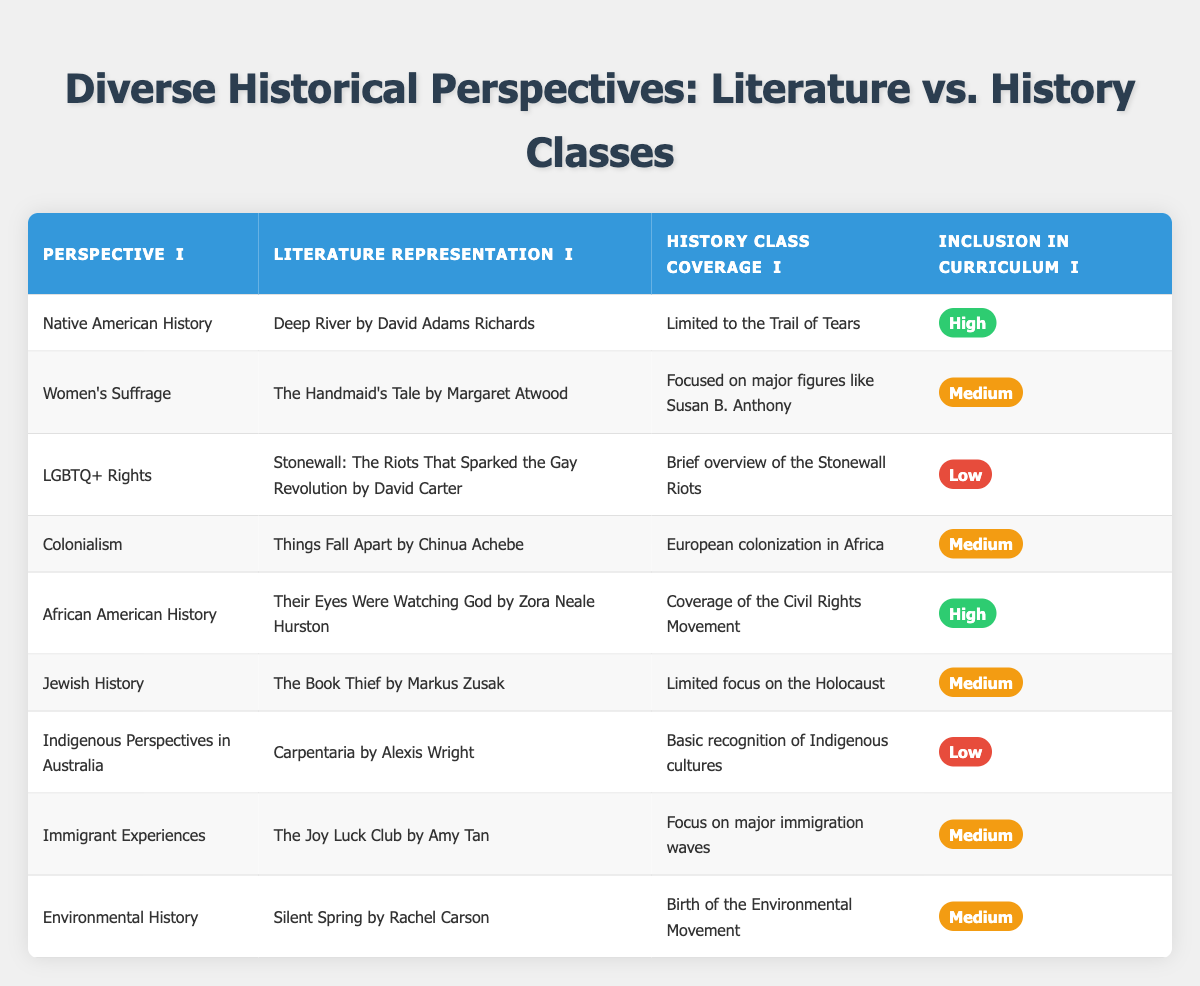What is the literature representation for African American History? According to the table, the literature representation for African American History is "Their Eyes Were Watching God by Zora Neale Hurston".
Answer: Their Eyes Were Watching God by Zora Neale Hurston Is the inclusion of LGBTQ+ Rights in the curriculum labeled as high? The table indicates that the inclusion of LGBTQ+ Rights in the curriculum is labeled as low, not high.
Answer: No Which perspective has the highest inclusion rating? There are two perspectives with high inclusion ratings listed: Native American History and African American History, each marked as high in the inclusion column.
Answer: Native American History and African American History What is the difference in inclusion ratings between Native American History and Jewish History? The inclusion rating for Native American History is high, while for Jewish History it is medium. Thus, the difference is high (any rating above medium) compared to medium.
Answer: High Are the history class coverage for Colonialism and Immigrant Experiences both considered medium? Yes, both Colonialism and Immigrant Experiences have their history class coverage labeled as medium, confirming that they are equal in this aspect.
Answer: Yes What is the average inclusion rating for the historical perspectives covered in literature with high inclusion? There are 2 perspectives with high inclusion: Native American History and African American History, which contribute to the average: (High + High) = 2. Thus it translates to High inclusion.
Answer: High In how many perspectives is the literature representation associated with female authors? The literature representation associated with female authors includes "The Handmaid's Tale" and "The Joy Luck Club", which indicates a total of 2 female authors in the table.
Answer: 2 Is the representation of Indigenous Perspectives in Australia covered more extensively in literature or history classes? The table shows that Indigenous Perspectives in Australia have a literature representation of "Carpentaria" but have only basic recognition in history classes, suggesting literature representation is more extensive.
Answer: Literature What perspectives have a focus on major events or movements in their history class coverage? The perspectives highlighting major events or movements include African American History (Civil Rights Movement), Women's Suffrage (major figures), and Environmental History (birth of the environmental movement), reflecting significant historical focus.
Answer: 3 perspectives 